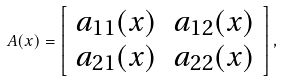<formula> <loc_0><loc_0><loc_500><loc_500>A ( x ) = \left [ \begin{array} { c c } a _ { 1 1 } ( x ) & a _ { 1 2 } ( x ) \\ a _ { 2 1 } ( x ) & a _ { 2 2 } ( x ) \\ \end{array} \right ] ,</formula> 